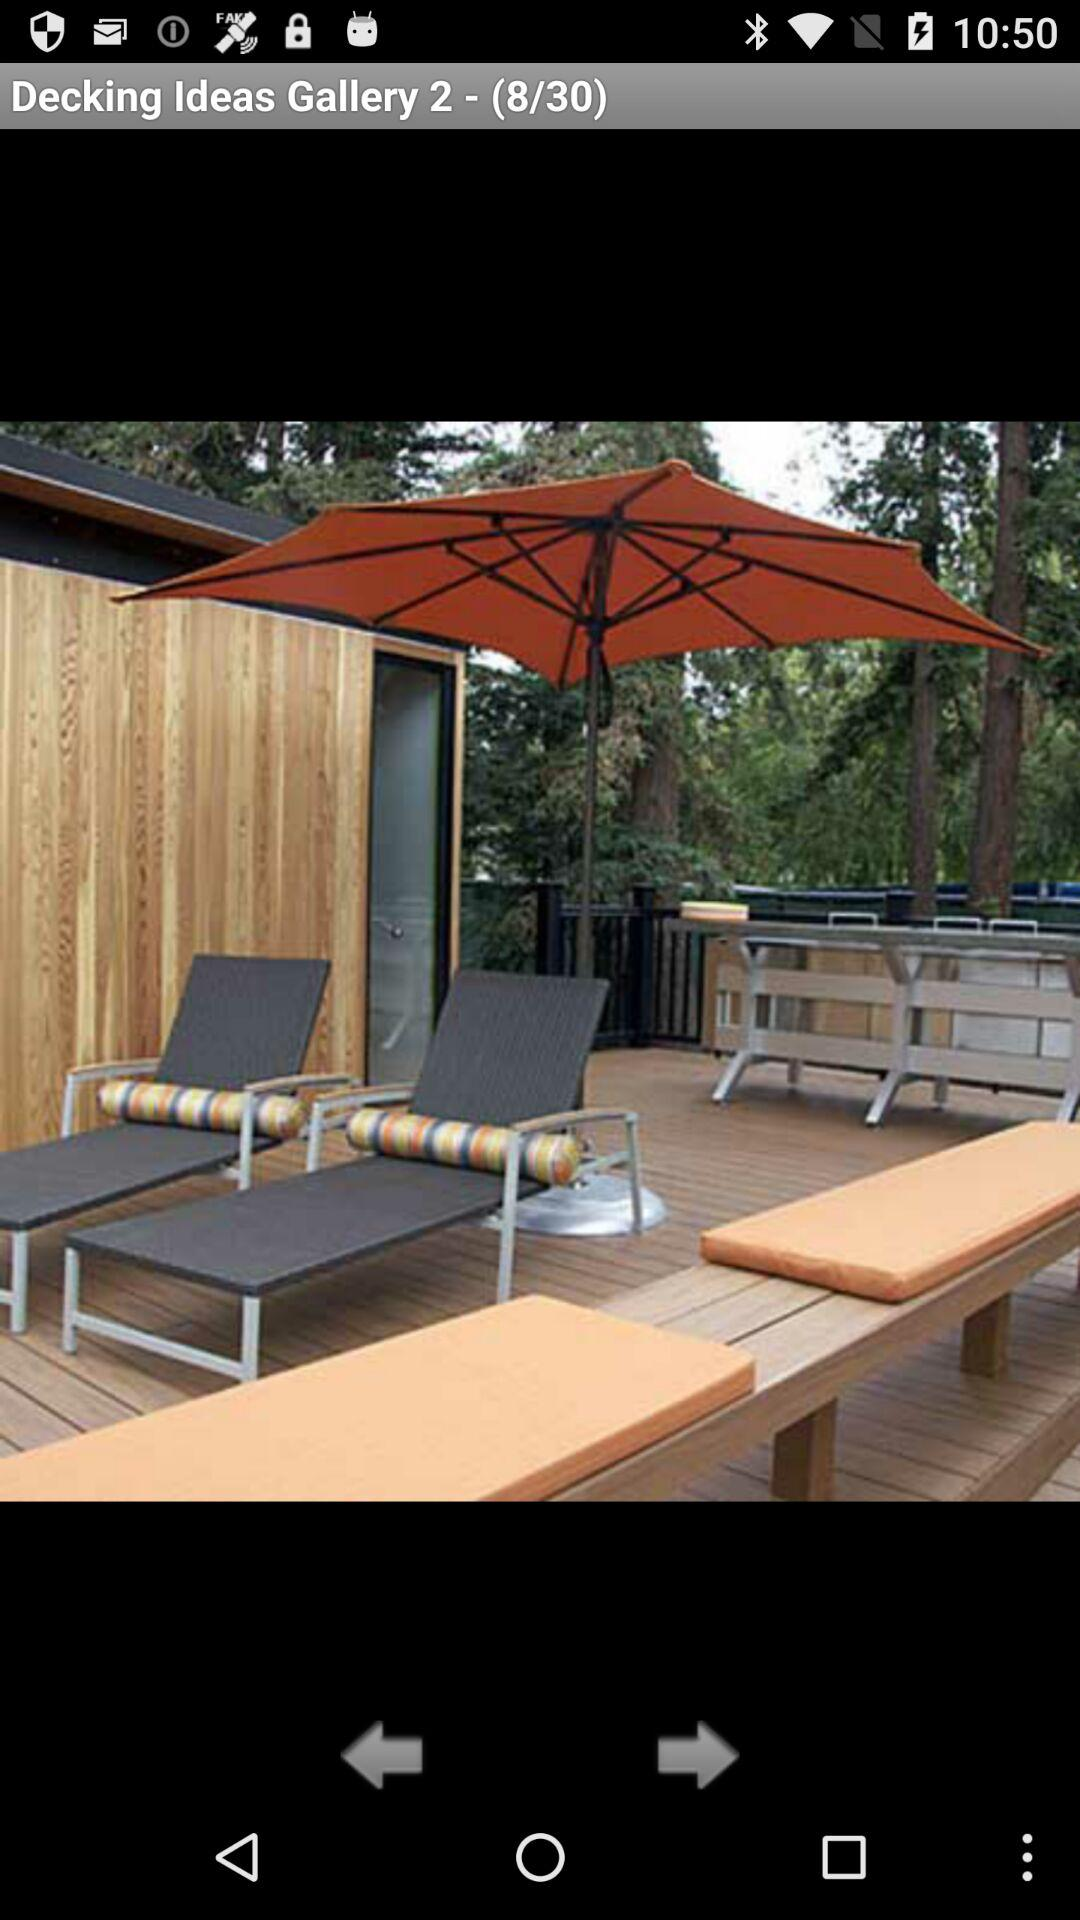How many images in total are there? There are 30 images in total. 